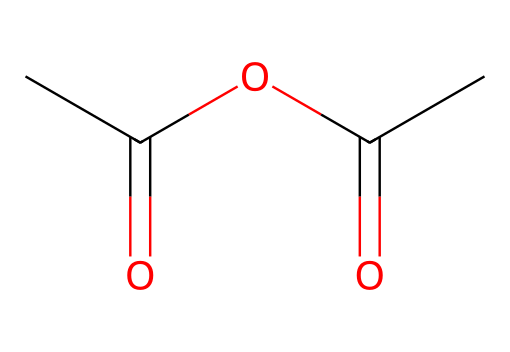What is the name of this chemical? The chemical structure provided corresponds to acetic anhydride, which is commonly known due to its use in various chemical reactions and industries.
Answer: acetic anhydride How many carbon atoms are in acetic anhydride? By analyzing the SMILES representation, it can be seen that there are four carbon atoms denoted by "C" markers in the structure.
Answer: four What is the functional group present in acetic anhydride? The structure contains an anhydride functional group, characterized by the presence of two acyl groups linked through an oxygen atom.
Answer: anhydride What is the total number of oxygen atoms in acetic anhydride? In the structure, there are two instances of the "O" present in the SMILES notation, indicating two oxygen atoms in acetic anhydride.
Answer: two Does acetic anhydride contain any hydrogen atoms? Each of the carbon atoms in acetic anhydride is associated with hydrogen atoms; specifically, there are six hydrogen atoms represented in the structure.
Answer: six What type of chemical is acetic anhydride classified as? Acetic anhydride falls under the category of acid anhydrides, which are typically a pair of carbonyl compounds (acyls) derived from the dehydration of acids.
Answer: acid anhydride Why is acetic anhydride significant for cellulose acetate production? Acetic anhydride is essential for cellulose acetate synthesis as it reacts with cellulose fibers to form acetate, which contributes to its biodegradable properties.
Answer: biodegradable material 